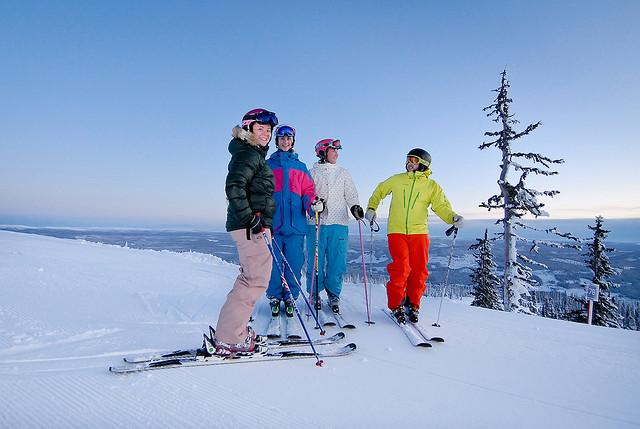Why are they stopped?

Choices:
A) eating lunch
B) lost
C) resting
D) at summit at summit 